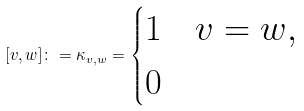<formula> <loc_0><loc_0><loc_500><loc_500>[ v , w ] \colon = \kappa _ { v , w } = \begin{cases} 1 & v = w , \\ 0 & \end{cases}</formula> 